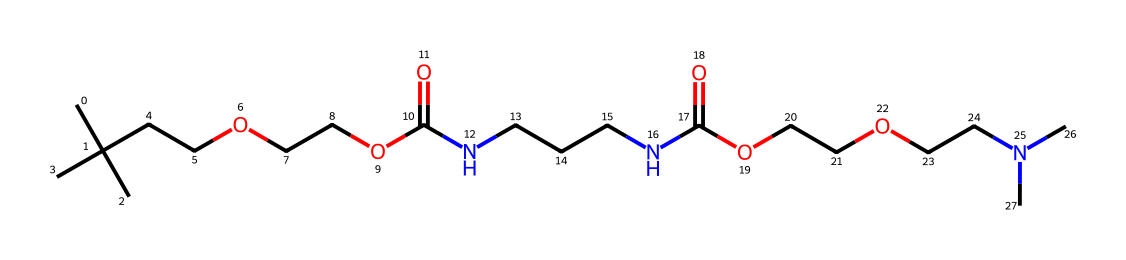How many carbon atoms are in the chemical? By analyzing the SMILES representation, I identify each "C" as a carbon atom, counting a total of 12 carbon atoms present in the structure.
Answer: 12 What is the functional group present in this compound? Observing the structure, I can see the presence of an amide group (NC(=O)) and an ether group (OCCO) in the chemical, but the main functional group reflected is the amide group due to the nitrogen bonded to a carbonyl.
Answer: amide How many nitrogen atoms are present in the chemical? By reviewing the SMILES, I recognize there are three distinct "N" atoms scattered within the chain, indicating three nitrogen atoms in total.
Answer: 3 What type of polymer does this structure suggest? Given the complex structure and presence of both amine and isocyanate components, this SMILES representation suggests that this compound forms a polyurethane polymer, commonly used in cushioning materials.
Answer: polyurethane What linkage types are present in this chemical? The presence of amide (–C(=O)N–), ether (–O–), and aliphatic linkages indicates several types of chemical linkages throughout the structure. Therefore, the linkages can be classified as amide and ether linkages.
Answer: amide and ether What property could affect the flexibility of this cushion material? The intermolecular forces derived from the polar amide groups will significantly influence the material's flexibility; stronger hydrogen bonding leads to lower flexibility, while weaker interactions promote flexibility.
Answer: hydrogen bonding How does the presence of nitrogen affect the properties of this cushioning material? The nitrogen incorporation leads to the formation of amide bonds, which provide enhanced mechanical stability and flexibility, affecting the cushioning and resilience qualities of the final polymer product.
Answer: enhances stability and flexibility 